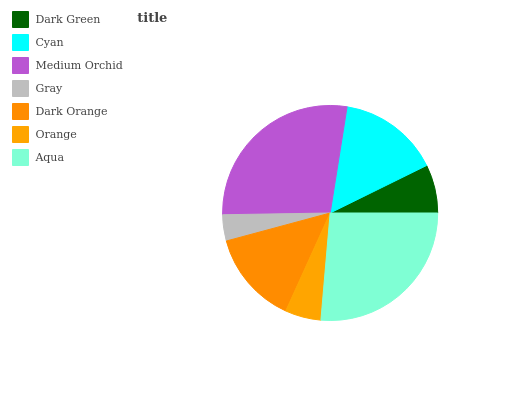Is Gray the minimum?
Answer yes or no. Yes. Is Medium Orchid the maximum?
Answer yes or no. Yes. Is Cyan the minimum?
Answer yes or no. No. Is Cyan the maximum?
Answer yes or no. No. Is Cyan greater than Dark Green?
Answer yes or no. Yes. Is Dark Green less than Cyan?
Answer yes or no. Yes. Is Dark Green greater than Cyan?
Answer yes or no. No. Is Cyan less than Dark Green?
Answer yes or no. No. Is Dark Orange the high median?
Answer yes or no. Yes. Is Dark Orange the low median?
Answer yes or no. Yes. Is Gray the high median?
Answer yes or no. No. Is Aqua the low median?
Answer yes or no. No. 